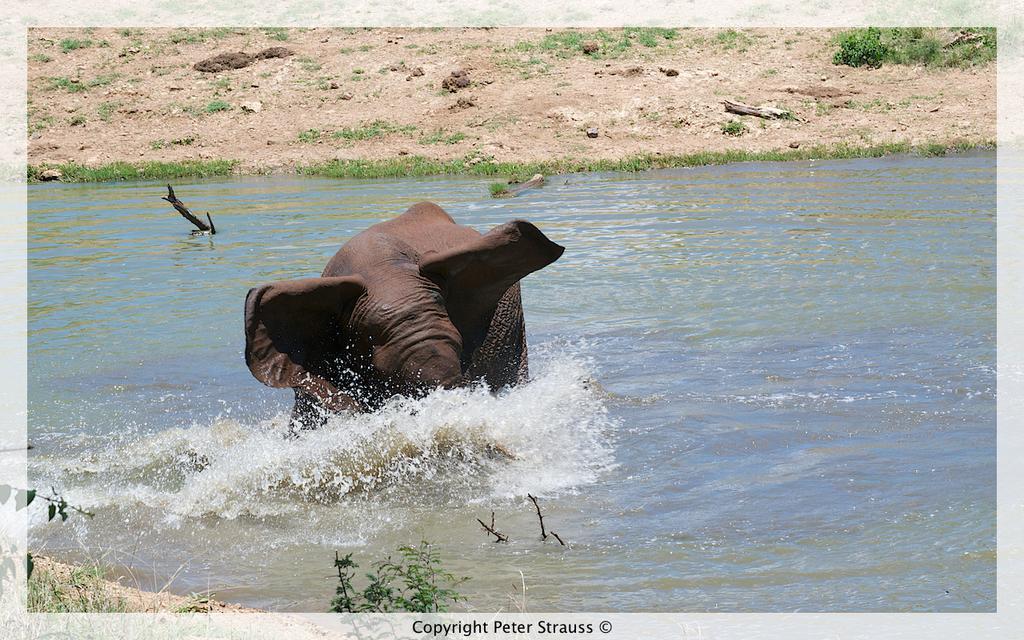Describe this image in one or two sentences. In this image we can see an elephant standing in the water, plants, grass and ground. 